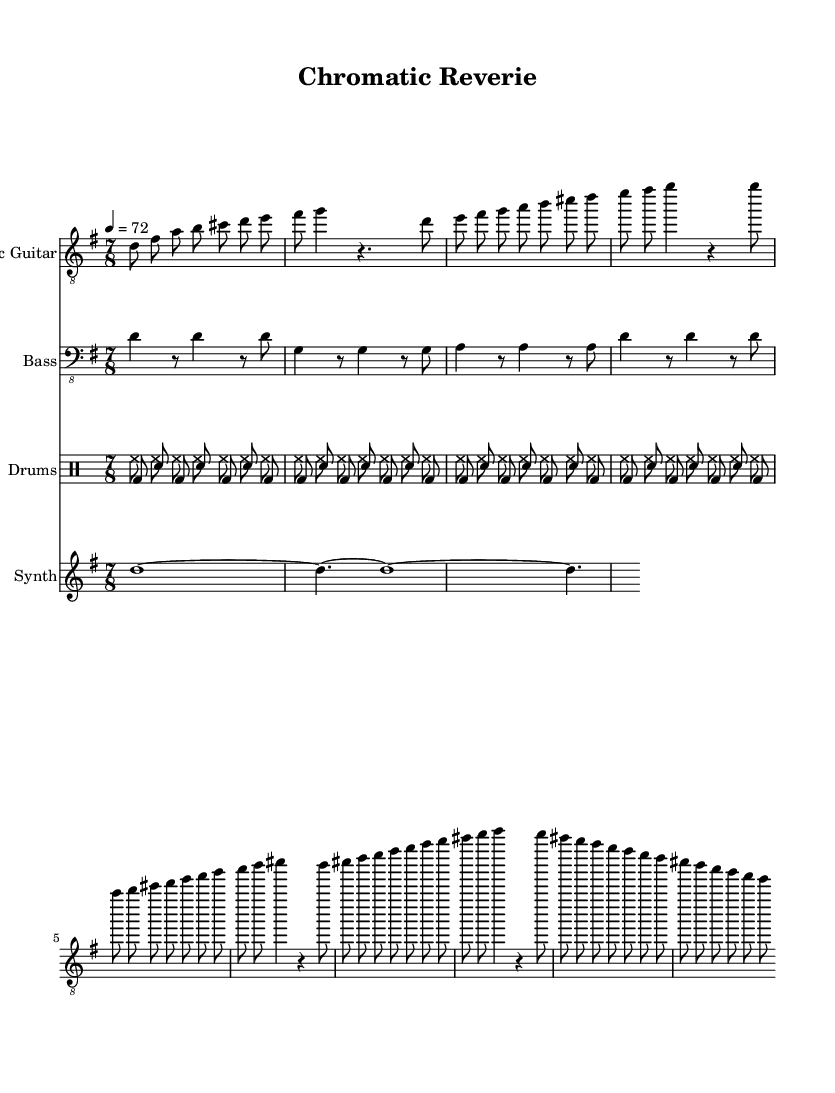What is the key signature of this music? The key signature is indicated by the absence of sharps or flats in the music sheet. The piece is in D major, which has two sharps (F# and C#) but is presented in its Mixolydian mode without emphasizing those sharps.
Answer: D Mixolydian What is the time signature of this piece? The time signature is shown at the beginning of the sheet music. It specifies that there are seven beats in each measure, indicating a 7/8 time signature.
Answer: 7/8 What is the tempo marking for this composition? The tempo marking appears at the beginning of the score, showing a metronome marking of 72 beats per minute, indicating a moderate pace.
Answer: 72 How many measures are in the electric guitar part? By counting the successive groupings of notes or rests in the electric guitar part, we find there are four distinct sections: an intro, a verse, a chorus, and a bridge, all fairly equal in length. Each section repeats enough to indicate a total of 18 measures.
Answer: 18 What rhythmic pattern does the drum set use? The drum part shows a combination of kick and snare drums with a repeating pattern in 7/8 time, alternating between bass drum beats and snare hits. This establishes a syncopated feel typical in rock music.
Answer: Alternating bass and snare What melodic role does the synthesizer play in this piece? The synthesizer section consists of long, sustained notes that support the harmonic structure of the music without providing rhythmic drive, acting as a textural layer.
Answer: Sustained notes How does the bass guitar contribute to the overall groove of the piece? The bass guitar provides a syncopated rhythmic underpinning that emphasizes the first, third, and sixth beats of the measure, creating a solid foundation for the other instruments to build upon in a rock context.
Answer: Syncopated foundation 